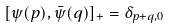Convert formula to latex. <formula><loc_0><loc_0><loc_500><loc_500>[ \psi ( p ) , { \bar { \psi } } ( q ) ] _ { + } = \delta _ { p + q , 0 }</formula> 